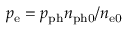<formula> <loc_0><loc_0><loc_500><loc_500>p _ { e } = p _ { p h } n _ { p h 0 } / n _ { e 0 }</formula> 